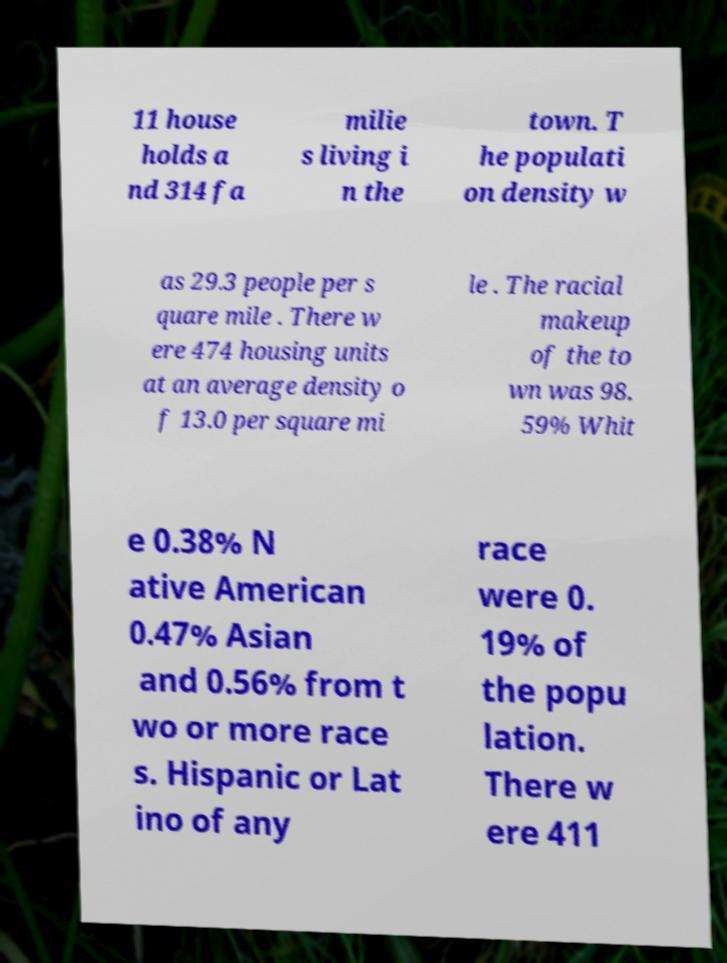Could you assist in decoding the text presented in this image and type it out clearly? 11 house holds a nd 314 fa milie s living i n the town. T he populati on density w as 29.3 people per s quare mile . There w ere 474 housing units at an average density o f 13.0 per square mi le . The racial makeup of the to wn was 98. 59% Whit e 0.38% N ative American 0.47% Asian and 0.56% from t wo or more race s. Hispanic or Lat ino of any race were 0. 19% of the popu lation. There w ere 411 